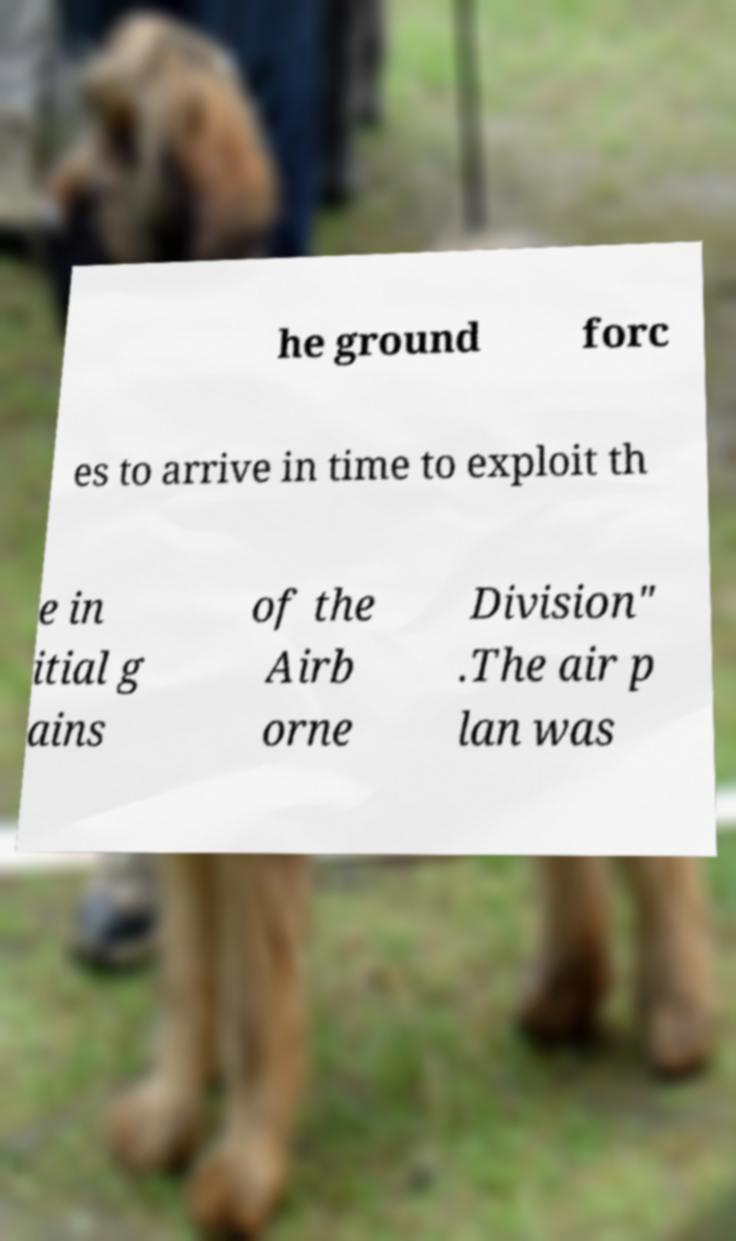Could you extract and type out the text from this image? he ground forc es to arrive in time to exploit th e in itial g ains of the Airb orne Division" .The air p lan was 